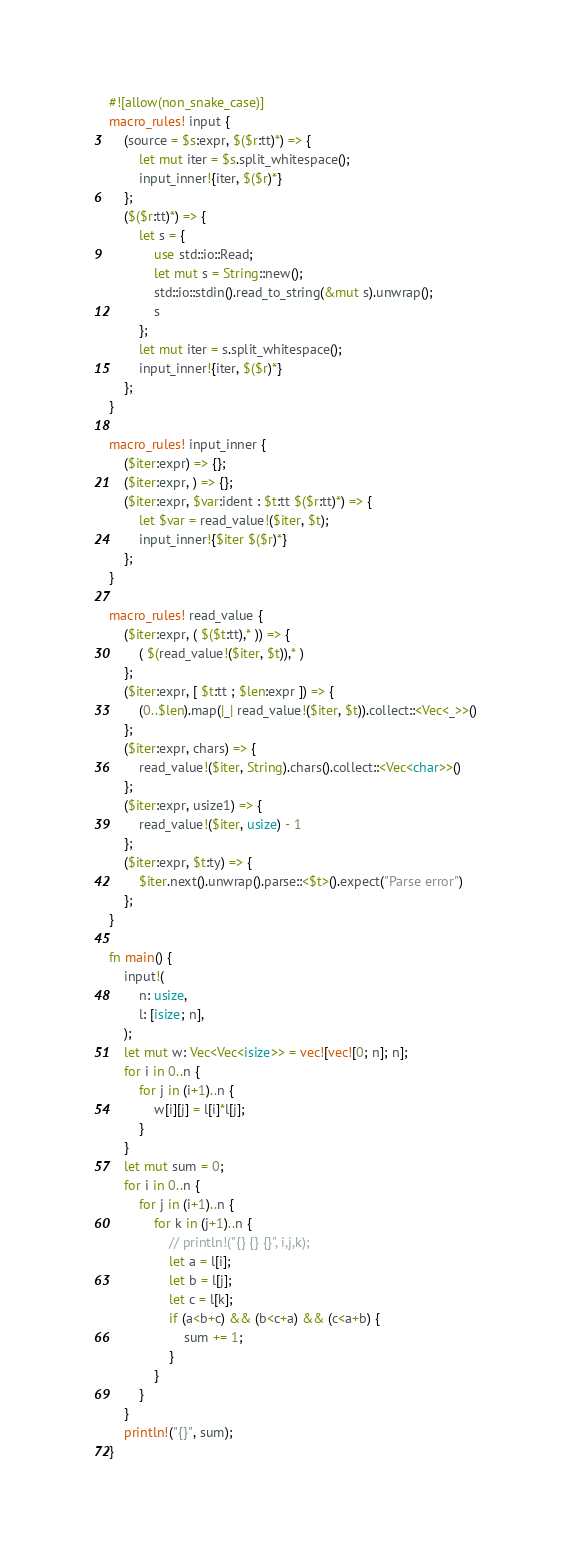<code> <loc_0><loc_0><loc_500><loc_500><_Rust_>#![allow(non_snake_case)]
macro_rules! input {
    (source = $s:expr, $($r:tt)*) => {
        let mut iter = $s.split_whitespace();
        input_inner!{iter, $($r)*}
    };
    ($($r:tt)*) => {
        let s = {
            use std::io::Read;
            let mut s = String::new();
            std::io::stdin().read_to_string(&mut s).unwrap();
            s
        };
        let mut iter = s.split_whitespace();
        input_inner!{iter, $($r)*}
    };
}

macro_rules! input_inner {
    ($iter:expr) => {};
    ($iter:expr, ) => {};
    ($iter:expr, $var:ident : $t:tt $($r:tt)*) => {
        let $var = read_value!($iter, $t);
        input_inner!{$iter $($r)*}
    };
}

macro_rules! read_value {
    ($iter:expr, ( $($t:tt),* )) => {
        ( $(read_value!($iter, $t)),* )
    };
    ($iter:expr, [ $t:tt ; $len:expr ]) => {
        (0..$len).map(|_| read_value!($iter, $t)).collect::<Vec<_>>()
    };
    ($iter:expr, chars) => {
        read_value!($iter, String).chars().collect::<Vec<char>>()
    };
    ($iter:expr, usize1) => {
        read_value!($iter, usize) - 1
    };
    ($iter:expr, $t:ty) => {
        $iter.next().unwrap().parse::<$t>().expect("Parse error")
    };
}

fn main() {
    input!(
        n: usize,
        l: [isize; n],
    );
    let mut w: Vec<Vec<isize>> = vec![vec![0; n]; n];
    for i in 0..n {
        for j in (i+1)..n {
            w[i][j] = l[i]*l[j];
        }
    }
    let mut sum = 0;
    for i in 0..n {
        for j in (i+1)..n {
            for k in (j+1)..n {
                // println!("{} {} {}", i,j,k);
                let a = l[i];
                let b = l[j];
                let c = l[k];
                if (a<b+c) && (b<c+a) && (c<a+b) {
                    sum += 1;
                }
            }
        }
    }
    println!("{}", sum);
}
</code> 